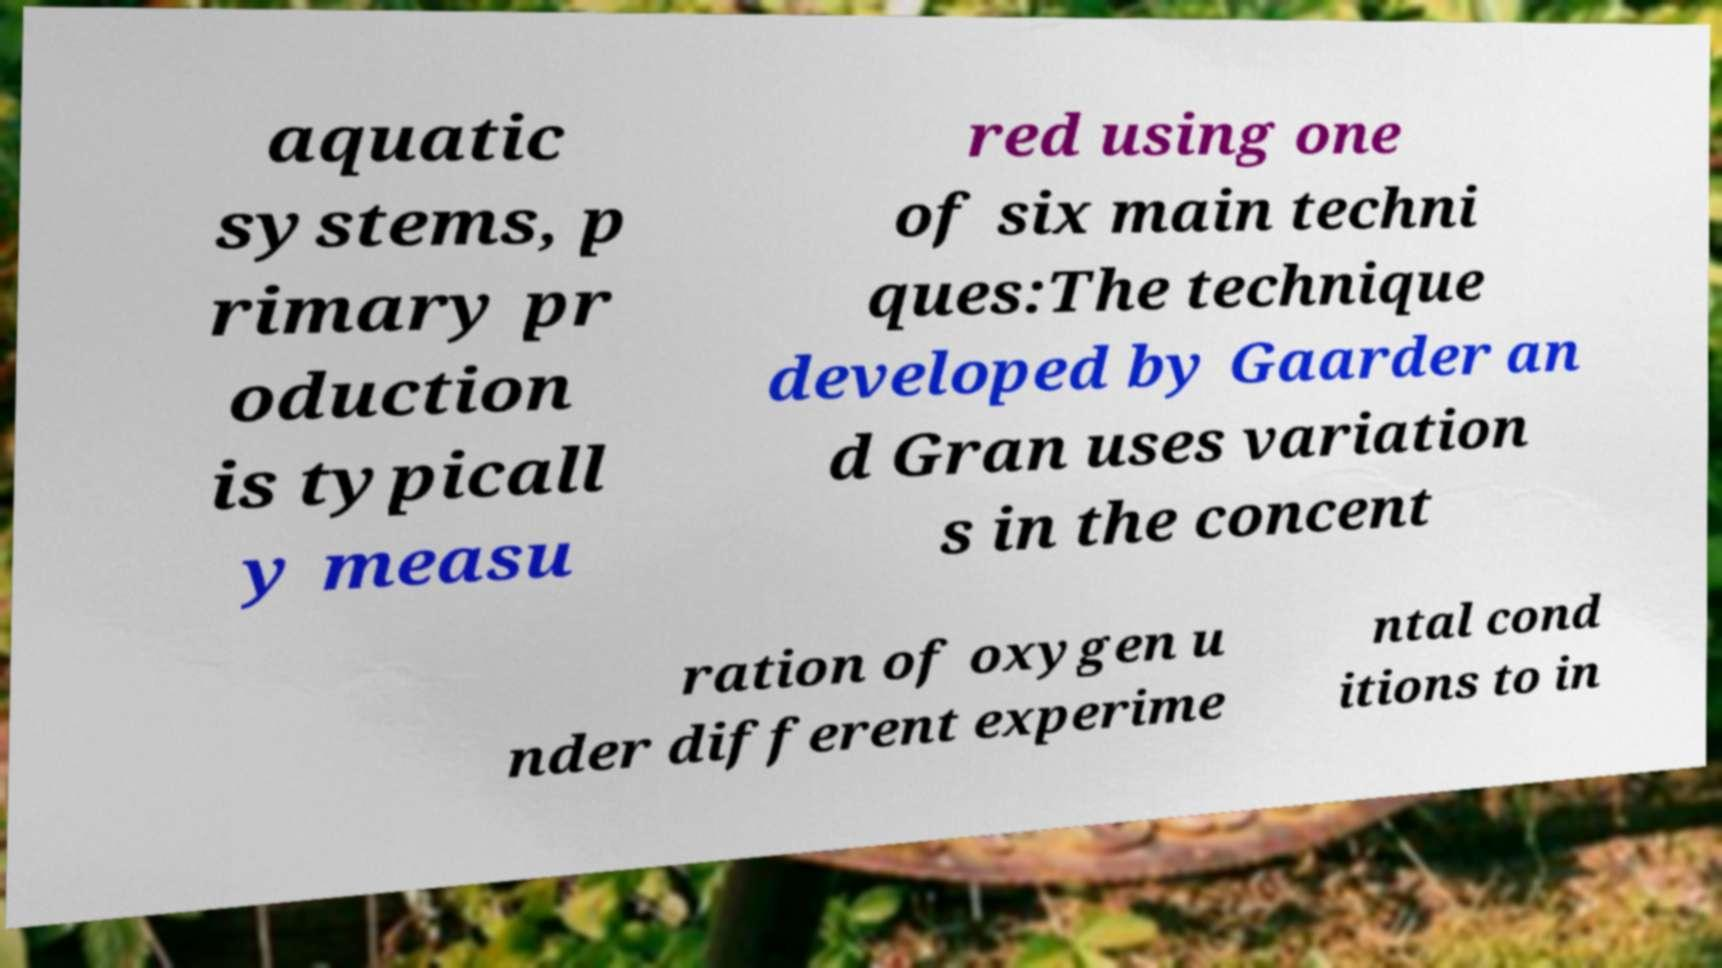Please read and relay the text visible in this image. What does it say? aquatic systems, p rimary pr oduction is typicall y measu red using one of six main techni ques:The technique developed by Gaarder an d Gran uses variation s in the concent ration of oxygen u nder different experime ntal cond itions to in 